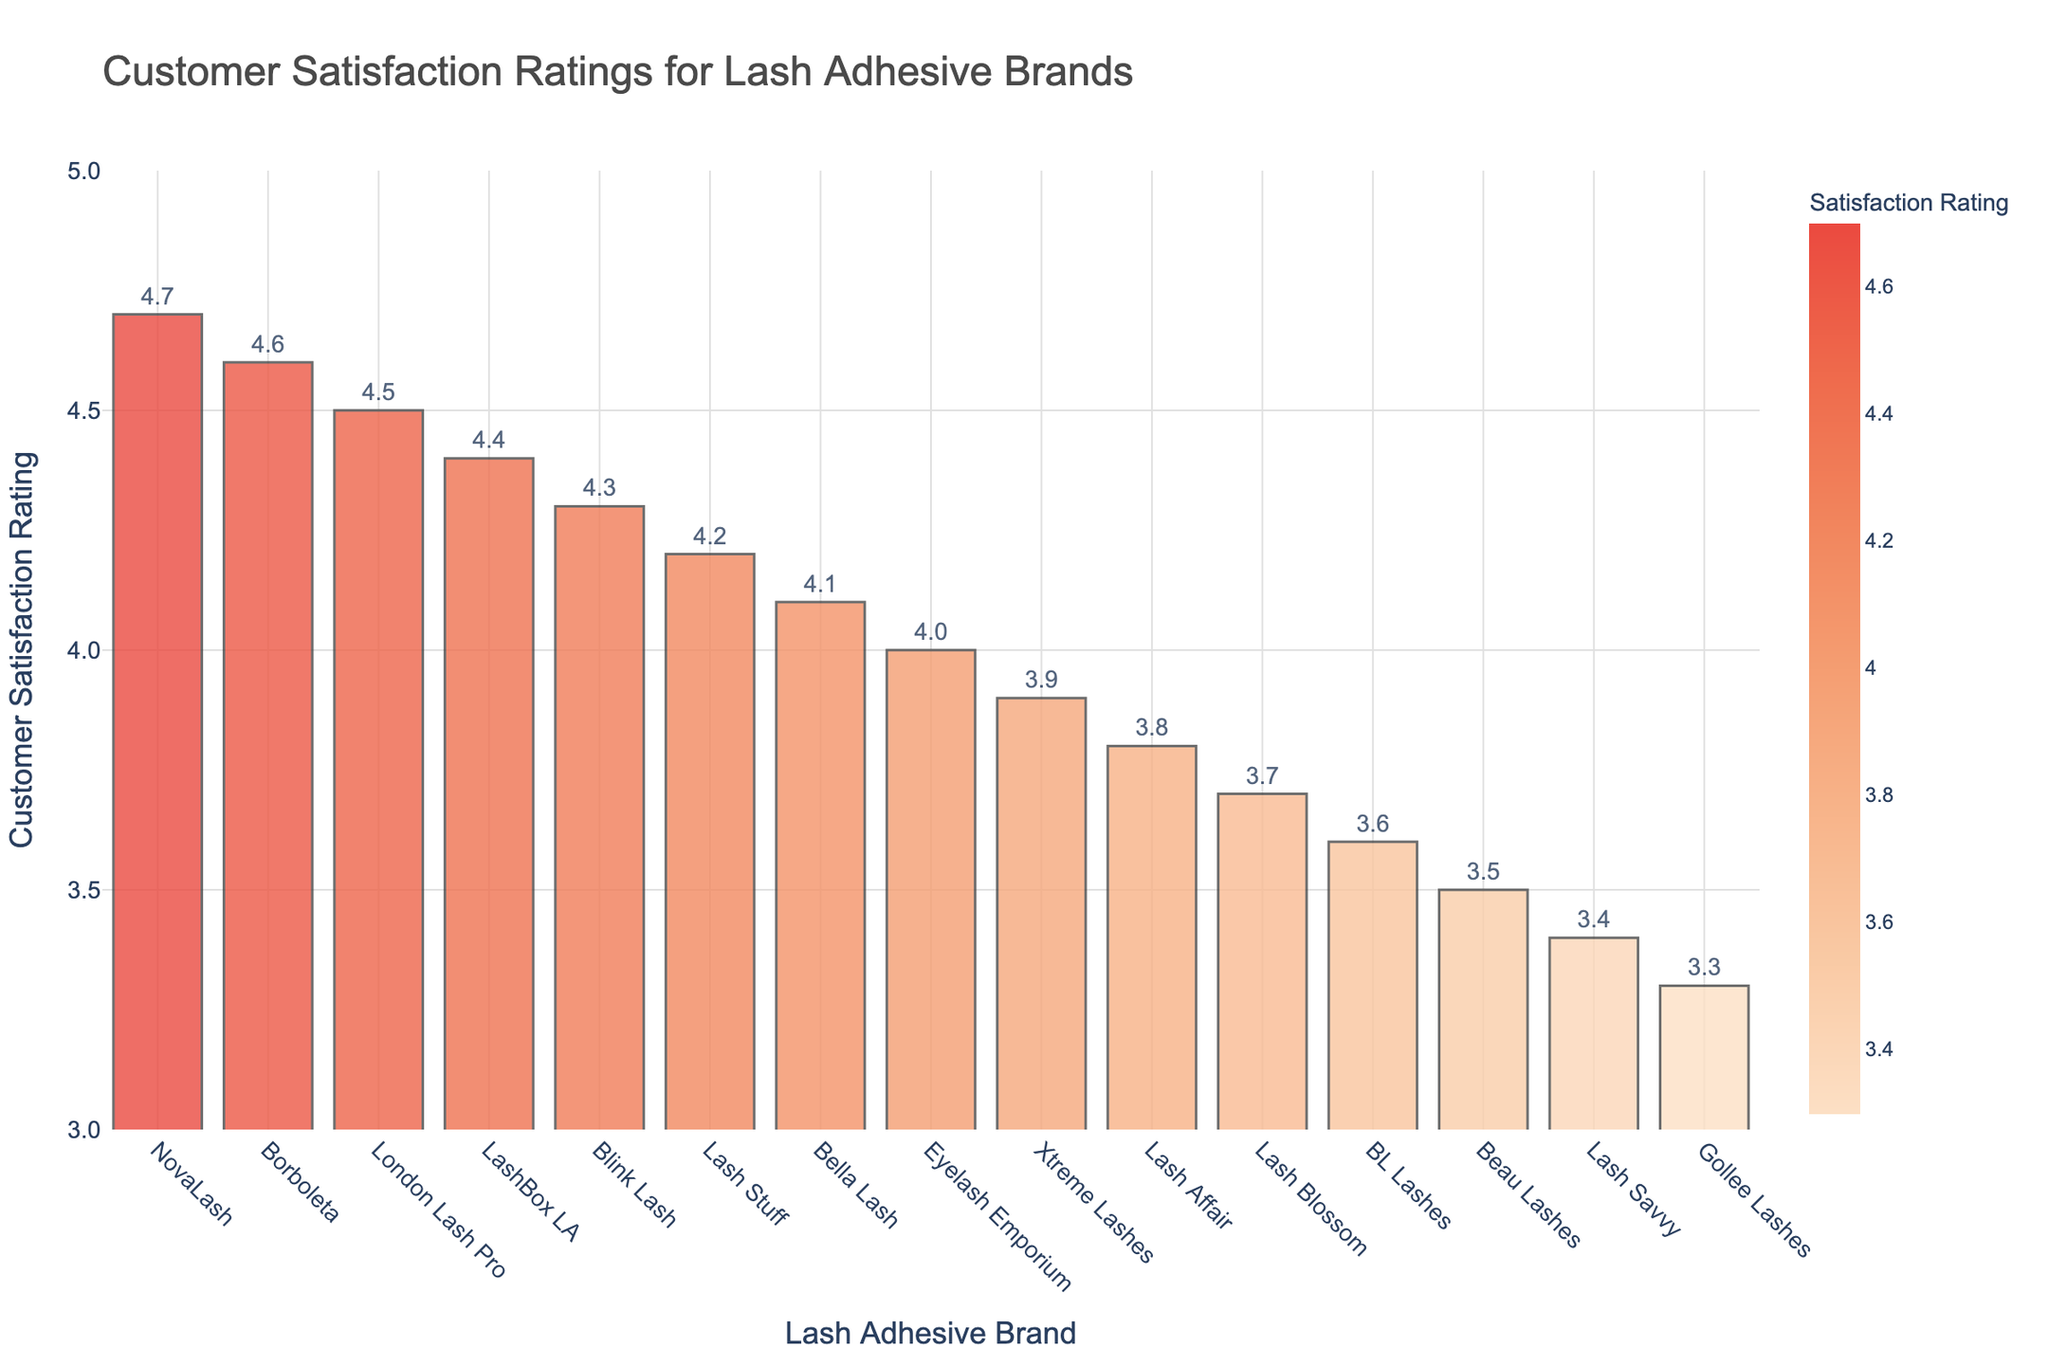Which brand has the highest customer satisfaction rating? The bar representing NovaLash reaches the highest point on the y-axis, which indicates it has the highest rating.
Answer: NovaLash Which two brands have the lowest customer satisfaction ratings? The bars representing Gollee Lashes and Lash Savvy are the shortest, meaning they have the lowest ratings.
Answer: Gollee Lashes and Lash Savvy What is the difference in satisfaction ratings between NovaLash and BL Lashes? NovaLash has a rating of 4.7, and BL Lashes has a rating of 3.6. Subtract the rating of BL Lashes from NovaLash's rating: 4.7 - 3.6 = 1.1.
Answer: 1.1 Which brand has a higher satisfaction rating, London Lash Pro or Bella Lash? The bar for London Lash Pro is higher than the bar for Bella Lash.
Answer: London Lash Pro How many brands have a customer satisfaction rating of 4.0 or above? Count the bars that reach or exceed the 4.0 mark on the y-axis. The brands are NovaLash, Borboleta, London Lash Pro, LashBox LA, Blink Lash, Lash Stuff, Bella Lash, and Eyelash Emporium, totaling 8 brands.
Answer: 8 What is the average satisfaction rating for the top three brands? Add the ratings of the top three brands: NovaLash (4.7), Borboleta (4.6), and London Lash Pro (4.5). Then divide by 3: (4.7 + 4.6 + 4.5) / 3 = 13.8 / 3 = 4.6.
Answer: 4.6 Compare the satisfaction rating of Blink Lash to that of BL Lashes. How much higher is Blink Lash’s rating? Blink Lash has a satisfaction rating of 4.3, and BL Lashes has a rating of 3.6. The difference is 4.3 - 3.6 = 0.7.
Answer: 0.7 Which brands fall into the middle range in terms of satisfaction ratings? (Consider middle range as 4.0 to 4.2) The brands with satisfaction ratings within 4.0 to 4.2 are Eyelash Emporium (4.0) and Lash Stuff (4.2).
Answer: Eyelash Emporium and Lash Stuff What is the combined satisfaction rating of the three lowest-rated brands? Add the ratings of the three lowest brands: Beau Lashes (3.5), Lash Savvy (3.4), and Gollee Lashes (3.3): 3.5 + 3.4 + 3.3 = 10.2.
Answer: 10.2 